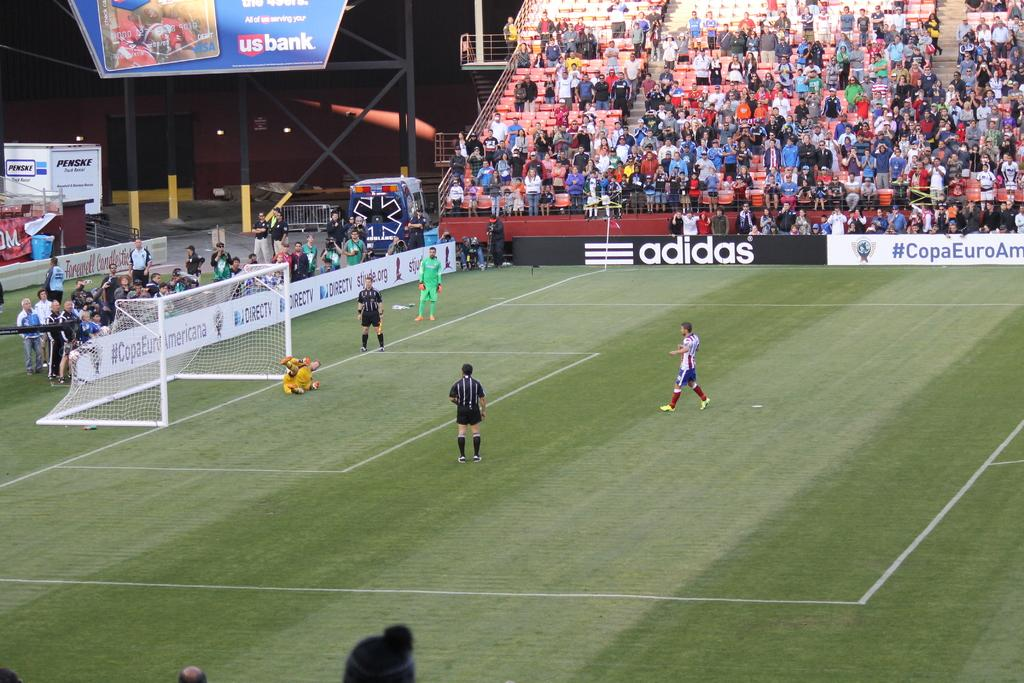<image>
Summarize the visual content of the image. Soccer players are assembled on a field with an Adidas sign on it. 